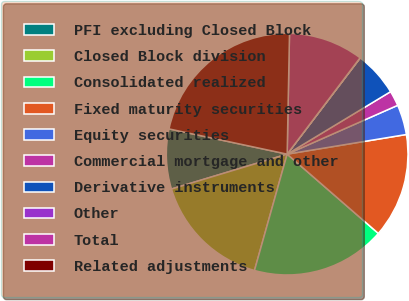Convert chart. <chart><loc_0><loc_0><loc_500><loc_500><pie_chart><fcel>PFI excluding Closed Block<fcel>Closed Block division<fcel>Consolidated realized<fcel>Fixed maturity securities<fcel>Equity securities<fcel>Commercial mortgage and other<fcel>Derivative instruments<fcel>Other<fcel>Total<fcel>Related adjustments<nl><fcel>8.01%<fcel>15.98%<fcel>17.97%<fcel>13.99%<fcel>4.02%<fcel>2.03%<fcel>6.01%<fcel>0.03%<fcel>10.0%<fcel>21.96%<nl></chart> 